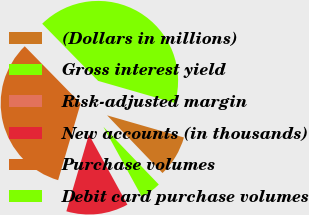Convert chart. <chart><loc_0><loc_0><loc_500><loc_500><pie_chart><fcel>(Dollars in millions)<fcel>Gross interest yield<fcel>Risk-adjusted margin<fcel>New accounts (in thousands)<fcel>Purchase volumes<fcel>Debit card purchase volumes<nl><fcel>8.36%<fcel>4.18%<fcel>0.0%<fcel>12.54%<fcel>33.13%<fcel>41.79%<nl></chart> 